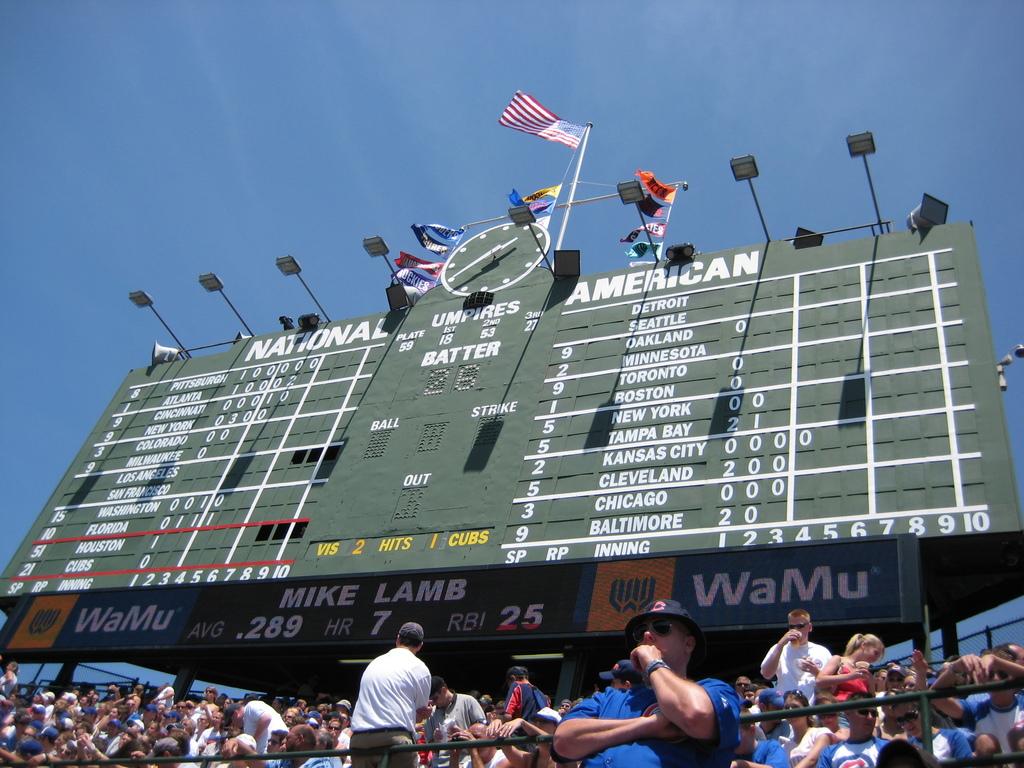What sports does wamu sponsor?
Ensure brevity in your answer.  Baseball. What team is on the left?
Give a very brief answer. National. 